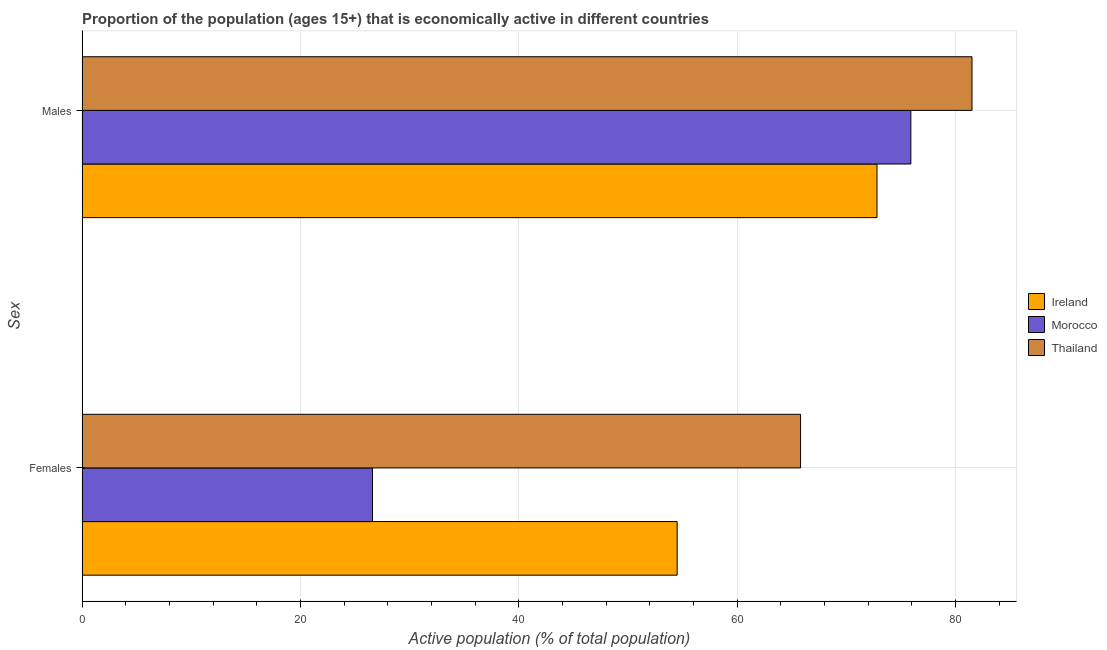How many groups of bars are there?
Offer a terse response. 2. Are the number of bars per tick equal to the number of legend labels?
Provide a succinct answer. Yes. Are the number of bars on each tick of the Y-axis equal?
Your response must be concise. Yes. How many bars are there on the 2nd tick from the top?
Provide a short and direct response. 3. How many bars are there on the 1st tick from the bottom?
Offer a terse response. 3. What is the label of the 1st group of bars from the top?
Keep it short and to the point. Males. What is the percentage of economically active female population in Thailand?
Your answer should be very brief. 65.8. Across all countries, what is the maximum percentage of economically active male population?
Keep it short and to the point. 81.5. Across all countries, what is the minimum percentage of economically active male population?
Offer a very short reply. 72.8. In which country was the percentage of economically active female population maximum?
Provide a succinct answer. Thailand. In which country was the percentage of economically active female population minimum?
Your answer should be very brief. Morocco. What is the total percentage of economically active female population in the graph?
Your answer should be compact. 146.9. What is the difference between the percentage of economically active male population in Thailand and that in Morocco?
Make the answer very short. 5.6. What is the difference between the percentage of economically active female population in Ireland and the percentage of economically active male population in Morocco?
Your response must be concise. -21.4. What is the average percentage of economically active male population per country?
Give a very brief answer. 76.73. What is the difference between the percentage of economically active female population and percentage of economically active male population in Ireland?
Keep it short and to the point. -18.3. In how many countries, is the percentage of economically active male population greater than 80 %?
Give a very brief answer. 1. What is the ratio of the percentage of economically active female population in Morocco to that in Ireland?
Your response must be concise. 0.49. In how many countries, is the percentage of economically active female population greater than the average percentage of economically active female population taken over all countries?
Your answer should be very brief. 2. What does the 1st bar from the top in Males represents?
Provide a short and direct response. Thailand. What does the 1st bar from the bottom in Females represents?
Ensure brevity in your answer.  Ireland. How many bars are there?
Offer a terse response. 6. Are all the bars in the graph horizontal?
Provide a succinct answer. Yes. How many countries are there in the graph?
Provide a short and direct response. 3. What is the difference between two consecutive major ticks on the X-axis?
Your response must be concise. 20. Does the graph contain any zero values?
Your answer should be compact. No. Does the graph contain grids?
Ensure brevity in your answer.  Yes. How many legend labels are there?
Your answer should be very brief. 3. What is the title of the graph?
Offer a terse response. Proportion of the population (ages 15+) that is economically active in different countries. Does "Ethiopia" appear as one of the legend labels in the graph?
Your answer should be compact. No. What is the label or title of the X-axis?
Make the answer very short. Active population (% of total population). What is the label or title of the Y-axis?
Keep it short and to the point. Sex. What is the Active population (% of total population) of Ireland in Females?
Ensure brevity in your answer.  54.5. What is the Active population (% of total population) of Morocco in Females?
Your answer should be very brief. 26.6. What is the Active population (% of total population) of Thailand in Females?
Your answer should be compact. 65.8. What is the Active population (% of total population) of Ireland in Males?
Provide a short and direct response. 72.8. What is the Active population (% of total population) of Morocco in Males?
Make the answer very short. 75.9. What is the Active population (% of total population) in Thailand in Males?
Provide a succinct answer. 81.5. Across all Sex, what is the maximum Active population (% of total population) in Ireland?
Offer a very short reply. 72.8. Across all Sex, what is the maximum Active population (% of total population) in Morocco?
Keep it short and to the point. 75.9. Across all Sex, what is the maximum Active population (% of total population) in Thailand?
Keep it short and to the point. 81.5. Across all Sex, what is the minimum Active population (% of total population) in Ireland?
Your response must be concise. 54.5. Across all Sex, what is the minimum Active population (% of total population) in Morocco?
Provide a succinct answer. 26.6. Across all Sex, what is the minimum Active population (% of total population) in Thailand?
Ensure brevity in your answer.  65.8. What is the total Active population (% of total population) of Ireland in the graph?
Offer a terse response. 127.3. What is the total Active population (% of total population) of Morocco in the graph?
Provide a succinct answer. 102.5. What is the total Active population (% of total population) in Thailand in the graph?
Offer a very short reply. 147.3. What is the difference between the Active population (% of total population) in Ireland in Females and that in Males?
Provide a succinct answer. -18.3. What is the difference between the Active population (% of total population) in Morocco in Females and that in Males?
Make the answer very short. -49.3. What is the difference between the Active population (% of total population) of Thailand in Females and that in Males?
Give a very brief answer. -15.7. What is the difference between the Active population (% of total population) in Ireland in Females and the Active population (% of total population) in Morocco in Males?
Make the answer very short. -21.4. What is the difference between the Active population (% of total population) in Morocco in Females and the Active population (% of total population) in Thailand in Males?
Ensure brevity in your answer.  -54.9. What is the average Active population (% of total population) of Ireland per Sex?
Your response must be concise. 63.65. What is the average Active population (% of total population) in Morocco per Sex?
Your answer should be compact. 51.25. What is the average Active population (% of total population) of Thailand per Sex?
Keep it short and to the point. 73.65. What is the difference between the Active population (% of total population) in Ireland and Active population (% of total population) in Morocco in Females?
Your response must be concise. 27.9. What is the difference between the Active population (% of total population) in Ireland and Active population (% of total population) in Thailand in Females?
Your response must be concise. -11.3. What is the difference between the Active population (% of total population) in Morocco and Active population (% of total population) in Thailand in Females?
Keep it short and to the point. -39.2. What is the difference between the Active population (% of total population) of Ireland and Active population (% of total population) of Thailand in Males?
Ensure brevity in your answer.  -8.7. What is the ratio of the Active population (% of total population) of Ireland in Females to that in Males?
Provide a succinct answer. 0.75. What is the ratio of the Active population (% of total population) in Morocco in Females to that in Males?
Make the answer very short. 0.35. What is the ratio of the Active population (% of total population) in Thailand in Females to that in Males?
Make the answer very short. 0.81. What is the difference between the highest and the second highest Active population (% of total population) in Ireland?
Offer a very short reply. 18.3. What is the difference between the highest and the second highest Active population (% of total population) in Morocco?
Your answer should be compact. 49.3. What is the difference between the highest and the lowest Active population (% of total population) of Morocco?
Ensure brevity in your answer.  49.3. What is the difference between the highest and the lowest Active population (% of total population) in Thailand?
Provide a short and direct response. 15.7. 